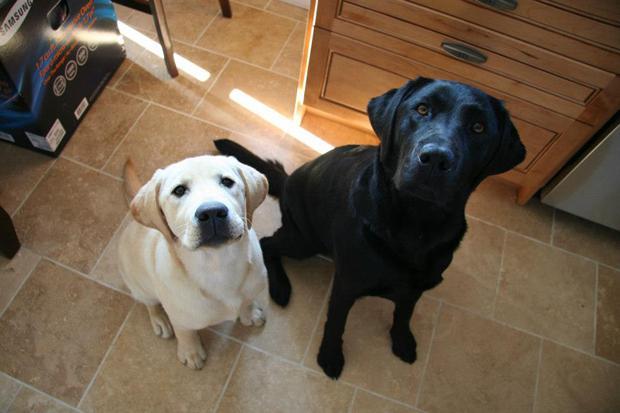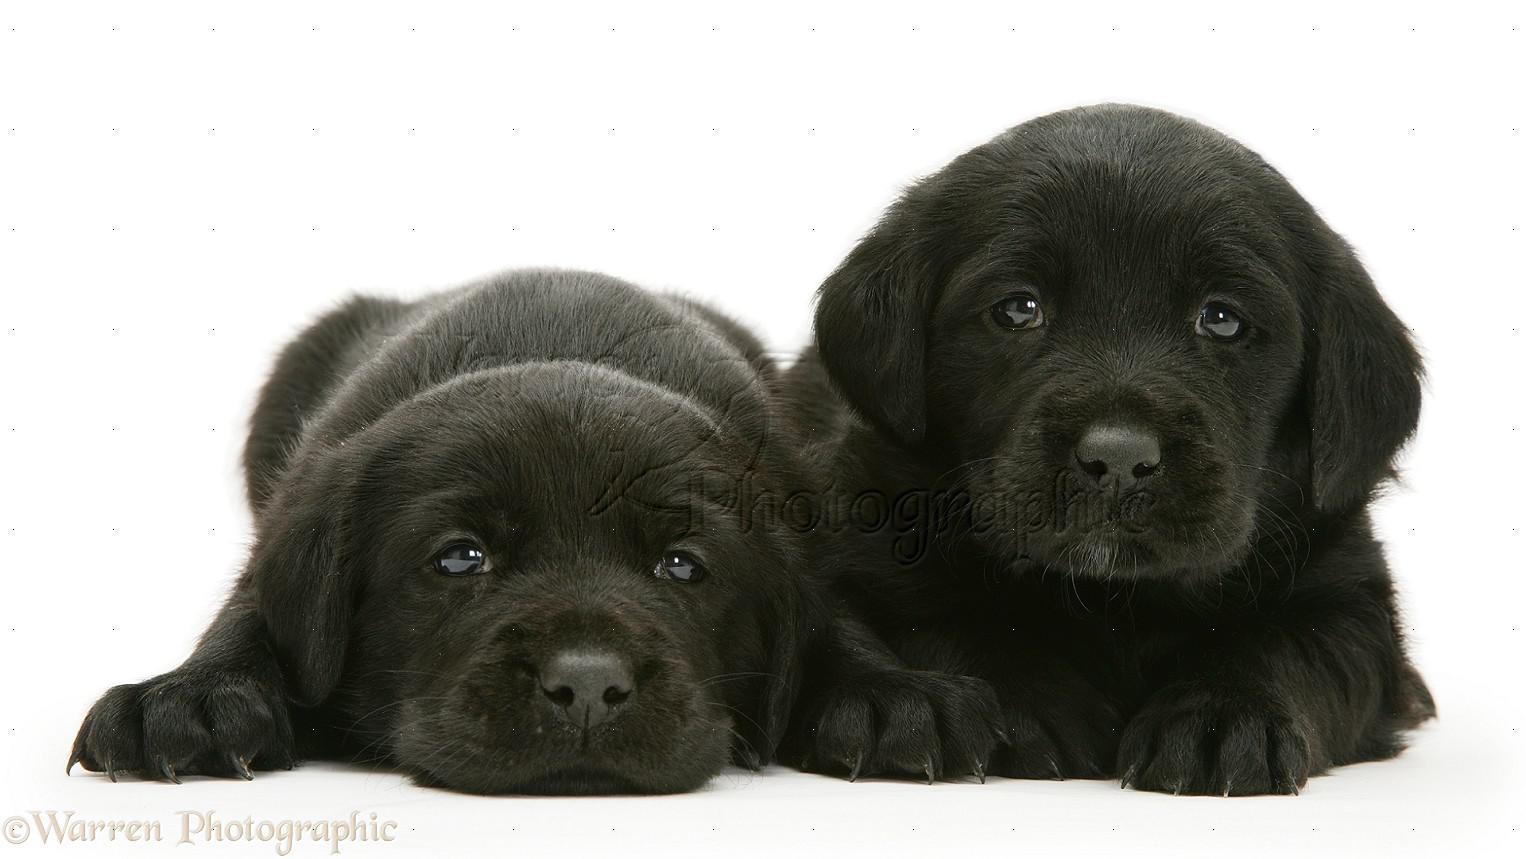The first image is the image on the left, the second image is the image on the right. For the images shown, is this caption "The left image features one golden and one black colored Labrador while the right image contains two chocolate or black lab puppies." true? Answer yes or no. Yes. The first image is the image on the left, the second image is the image on the right. Assess this claim about the two images: "An adult black dog and younger cream colored dog are together in an interior location, while in a second image, two puppies of the same color and breed snuggle together.". Correct or not? Answer yes or no. Yes. 